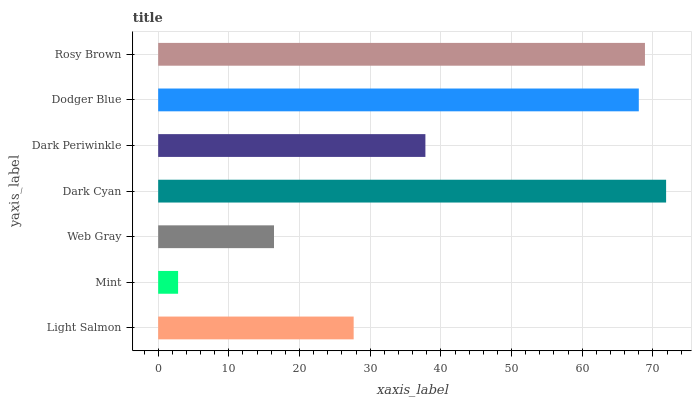Is Mint the minimum?
Answer yes or no. Yes. Is Dark Cyan the maximum?
Answer yes or no. Yes. Is Web Gray the minimum?
Answer yes or no. No. Is Web Gray the maximum?
Answer yes or no. No. Is Web Gray greater than Mint?
Answer yes or no. Yes. Is Mint less than Web Gray?
Answer yes or no. Yes. Is Mint greater than Web Gray?
Answer yes or no. No. Is Web Gray less than Mint?
Answer yes or no. No. Is Dark Periwinkle the high median?
Answer yes or no. Yes. Is Dark Periwinkle the low median?
Answer yes or no. Yes. Is Rosy Brown the high median?
Answer yes or no. No. Is Rosy Brown the low median?
Answer yes or no. No. 